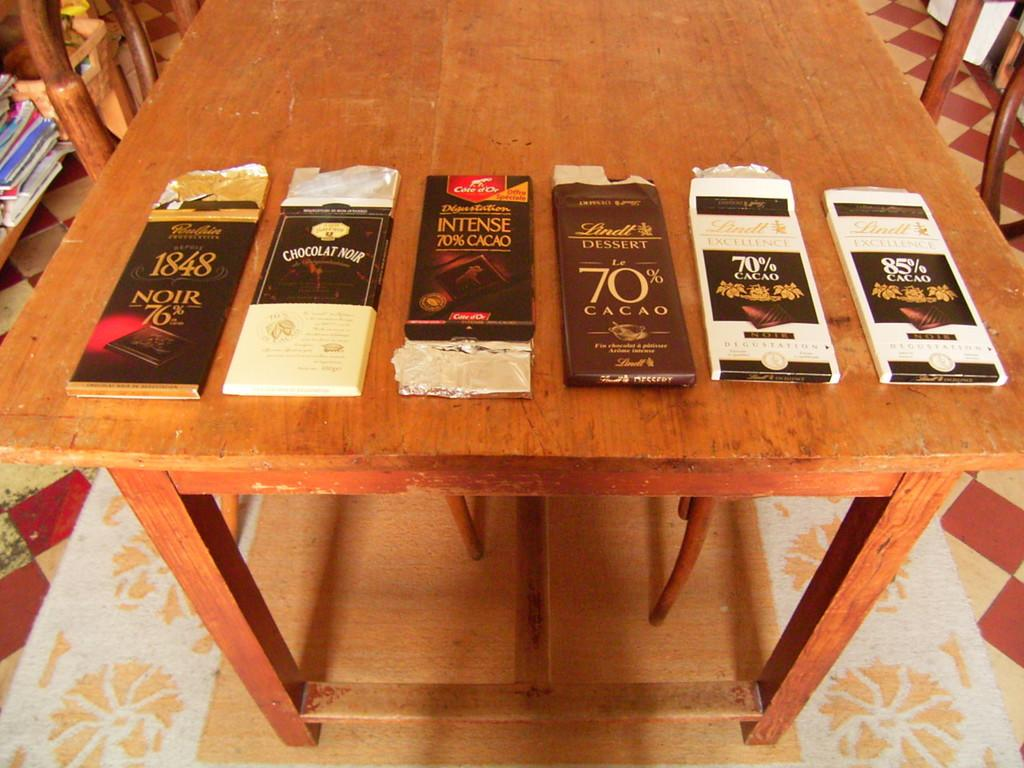Provide a one-sentence caption for the provided image. A variety of packets of Cacao for tasting. 